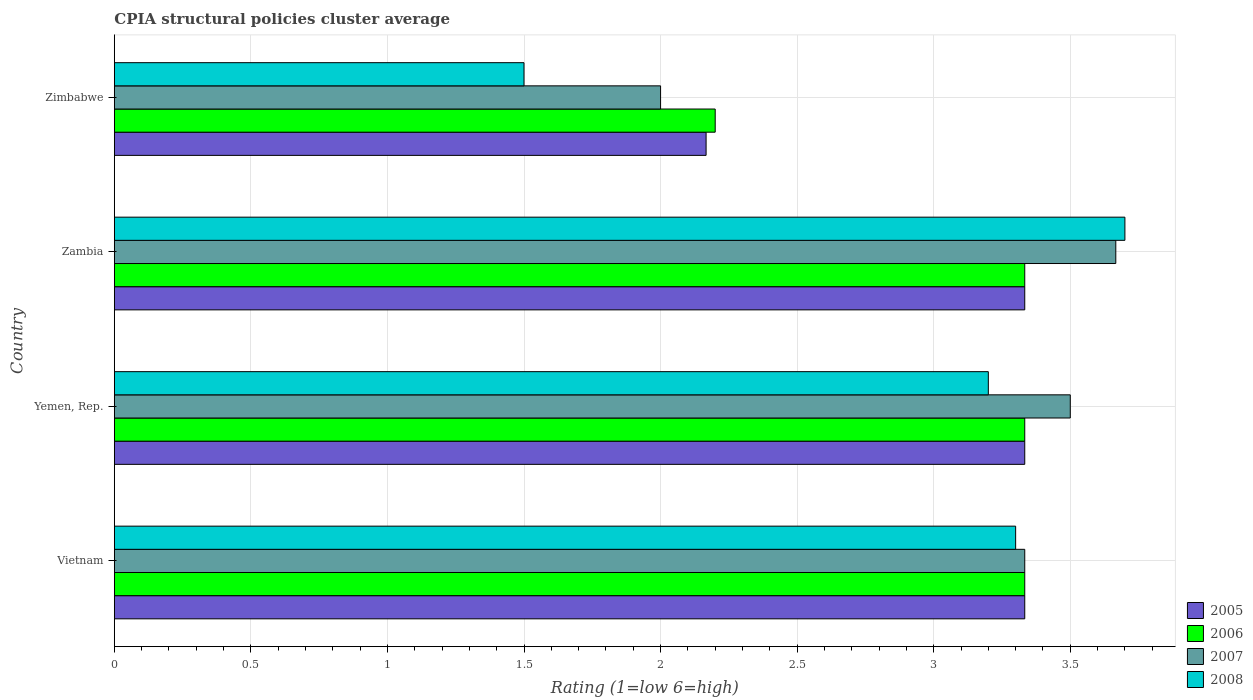How many different coloured bars are there?
Your answer should be compact. 4. How many groups of bars are there?
Offer a very short reply. 4. How many bars are there on the 1st tick from the top?
Make the answer very short. 4. What is the label of the 3rd group of bars from the top?
Offer a terse response. Yemen, Rep. In how many cases, is the number of bars for a given country not equal to the number of legend labels?
Provide a succinct answer. 0. What is the CPIA rating in 2008 in Yemen, Rep.?
Give a very brief answer. 3.2. Across all countries, what is the maximum CPIA rating in 2008?
Offer a terse response. 3.7. Across all countries, what is the minimum CPIA rating in 2007?
Offer a terse response. 2. In which country was the CPIA rating in 2008 maximum?
Ensure brevity in your answer.  Zambia. In which country was the CPIA rating in 2005 minimum?
Make the answer very short. Zimbabwe. What is the difference between the CPIA rating in 2005 in Vietnam and that in Zimbabwe?
Ensure brevity in your answer.  1.17. What is the difference between the CPIA rating in 2008 in Yemen, Rep. and the CPIA rating in 2007 in Zimbabwe?
Provide a succinct answer. 1.2. What is the average CPIA rating in 2005 per country?
Give a very brief answer. 3.04. What is the difference between the CPIA rating in 2006 and CPIA rating in 2007 in Yemen, Rep.?
Provide a succinct answer. -0.17. In how many countries, is the CPIA rating in 2007 greater than 3.7 ?
Make the answer very short. 0. What is the ratio of the CPIA rating in 2007 in Vietnam to that in Yemen, Rep.?
Provide a short and direct response. 0.95. Is the CPIA rating in 2006 in Zambia less than that in Zimbabwe?
Make the answer very short. No. What is the difference between the highest and the second highest CPIA rating in 2006?
Provide a short and direct response. 0. What is the difference between the highest and the lowest CPIA rating in 2008?
Make the answer very short. 2.2. In how many countries, is the CPIA rating in 2007 greater than the average CPIA rating in 2007 taken over all countries?
Give a very brief answer. 3. What does the 4th bar from the bottom in Zimbabwe represents?
Keep it short and to the point. 2008. Does the graph contain any zero values?
Make the answer very short. No. How many legend labels are there?
Your answer should be compact. 4. How are the legend labels stacked?
Make the answer very short. Vertical. What is the title of the graph?
Provide a succinct answer. CPIA structural policies cluster average. What is the label or title of the X-axis?
Make the answer very short. Rating (1=low 6=high). What is the Rating (1=low 6=high) in 2005 in Vietnam?
Keep it short and to the point. 3.33. What is the Rating (1=low 6=high) in 2006 in Vietnam?
Offer a very short reply. 3.33. What is the Rating (1=low 6=high) of 2007 in Vietnam?
Make the answer very short. 3.33. What is the Rating (1=low 6=high) in 2008 in Vietnam?
Provide a short and direct response. 3.3. What is the Rating (1=low 6=high) in 2005 in Yemen, Rep.?
Provide a succinct answer. 3.33. What is the Rating (1=low 6=high) of 2006 in Yemen, Rep.?
Make the answer very short. 3.33. What is the Rating (1=low 6=high) of 2005 in Zambia?
Your answer should be very brief. 3.33. What is the Rating (1=low 6=high) in 2006 in Zambia?
Your answer should be compact. 3.33. What is the Rating (1=low 6=high) of 2007 in Zambia?
Ensure brevity in your answer.  3.67. What is the Rating (1=low 6=high) of 2008 in Zambia?
Make the answer very short. 3.7. What is the Rating (1=low 6=high) of 2005 in Zimbabwe?
Provide a succinct answer. 2.17. Across all countries, what is the maximum Rating (1=low 6=high) of 2005?
Your answer should be compact. 3.33. Across all countries, what is the maximum Rating (1=low 6=high) of 2006?
Provide a short and direct response. 3.33. Across all countries, what is the maximum Rating (1=low 6=high) of 2007?
Your answer should be very brief. 3.67. Across all countries, what is the maximum Rating (1=low 6=high) of 2008?
Keep it short and to the point. 3.7. Across all countries, what is the minimum Rating (1=low 6=high) in 2005?
Offer a very short reply. 2.17. Across all countries, what is the minimum Rating (1=low 6=high) in 2006?
Provide a short and direct response. 2.2. What is the total Rating (1=low 6=high) of 2005 in the graph?
Offer a terse response. 12.17. What is the difference between the Rating (1=low 6=high) in 2006 in Vietnam and that in Yemen, Rep.?
Make the answer very short. 0. What is the difference between the Rating (1=low 6=high) in 2007 in Vietnam and that in Yemen, Rep.?
Give a very brief answer. -0.17. What is the difference between the Rating (1=low 6=high) in 2007 in Vietnam and that in Zambia?
Your answer should be very brief. -0.33. What is the difference between the Rating (1=low 6=high) of 2008 in Vietnam and that in Zambia?
Your answer should be very brief. -0.4. What is the difference between the Rating (1=low 6=high) of 2005 in Vietnam and that in Zimbabwe?
Your response must be concise. 1.17. What is the difference between the Rating (1=low 6=high) in 2006 in Vietnam and that in Zimbabwe?
Offer a very short reply. 1.13. What is the difference between the Rating (1=low 6=high) of 2007 in Vietnam and that in Zimbabwe?
Offer a terse response. 1.33. What is the difference between the Rating (1=low 6=high) of 2005 in Yemen, Rep. and that in Zambia?
Your answer should be very brief. 0. What is the difference between the Rating (1=low 6=high) of 2008 in Yemen, Rep. and that in Zambia?
Keep it short and to the point. -0.5. What is the difference between the Rating (1=low 6=high) in 2006 in Yemen, Rep. and that in Zimbabwe?
Provide a succinct answer. 1.13. What is the difference between the Rating (1=low 6=high) in 2007 in Yemen, Rep. and that in Zimbabwe?
Provide a short and direct response. 1.5. What is the difference between the Rating (1=low 6=high) in 2008 in Yemen, Rep. and that in Zimbabwe?
Your response must be concise. 1.7. What is the difference between the Rating (1=low 6=high) in 2005 in Zambia and that in Zimbabwe?
Offer a terse response. 1.17. What is the difference between the Rating (1=low 6=high) of 2006 in Zambia and that in Zimbabwe?
Your response must be concise. 1.13. What is the difference between the Rating (1=low 6=high) in 2005 in Vietnam and the Rating (1=low 6=high) in 2008 in Yemen, Rep.?
Your answer should be compact. 0.13. What is the difference between the Rating (1=low 6=high) in 2006 in Vietnam and the Rating (1=low 6=high) in 2007 in Yemen, Rep.?
Ensure brevity in your answer.  -0.17. What is the difference between the Rating (1=low 6=high) in 2006 in Vietnam and the Rating (1=low 6=high) in 2008 in Yemen, Rep.?
Offer a terse response. 0.13. What is the difference between the Rating (1=low 6=high) of 2007 in Vietnam and the Rating (1=low 6=high) of 2008 in Yemen, Rep.?
Provide a short and direct response. 0.13. What is the difference between the Rating (1=low 6=high) in 2005 in Vietnam and the Rating (1=low 6=high) in 2008 in Zambia?
Your response must be concise. -0.37. What is the difference between the Rating (1=low 6=high) of 2006 in Vietnam and the Rating (1=low 6=high) of 2007 in Zambia?
Your answer should be compact. -0.33. What is the difference between the Rating (1=low 6=high) of 2006 in Vietnam and the Rating (1=low 6=high) of 2008 in Zambia?
Make the answer very short. -0.37. What is the difference between the Rating (1=low 6=high) in 2007 in Vietnam and the Rating (1=low 6=high) in 2008 in Zambia?
Ensure brevity in your answer.  -0.37. What is the difference between the Rating (1=low 6=high) of 2005 in Vietnam and the Rating (1=low 6=high) of 2006 in Zimbabwe?
Provide a succinct answer. 1.13. What is the difference between the Rating (1=low 6=high) in 2005 in Vietnam and the Rating (1=low 6=high) in 2007 in Zimbabwe?
Make the answer very short. 1.33. What is the difference between the Rating (1=low 6=high) of 2005 in Vietnam and the Rating (1=low 6=high) of 2008 in Zimbabwe?
Your response must be concise. 1.83. What is the difference between the Rating (1=low 6=high) of 2006 in Vietnam and the Rating (1=low 6=high) of 2008 in Zimbabwe?
Provide a short and direct response. 1.83. What is the difference between the Rating (1=low 6=high) in 2007 in Vietnam and the Rating (1=low 6=high) in 2008 in Zimbabwe?
Give a very brief answer. 1.83. What is the difference between the Rating (1=low 6=high) of 2005 in Yemen, Rep. and the Rating (1=low 6=high) of 2008 in Zambia?
Ensure brevity in your answer.  -0.37. What is the difference between the Rating (1=low 6=high) in 2006 in Yemen, Rep. and the Rating (1=low 6=high) in 2008 in Zambia?
Your answer should be very brief. -0.37. What is the difference between the Rating (1=low 6=high) in 2007 in Yemen, Rep. and the Rating (1=low 6=high) in 2008 in Zambia?
Offer a very short reply. -0.2. What is the difference between the Rating (1=low 6=high) of 2005 in Yemen, Rep. and the Rating (1=low 6=high) of 2006 in Zimbabwe?
Ensure brevity in your answer.  1.13. What is the difference between the Rating (1=low 6=high) in 2005 in Yemen, Rep. and the Rating (1=low 6=high) in 2008 in Zimbabwe?
Provide a succinct answer. 1.83. What is the difference between the Rating (1=low 6=high) in 2006 in Yemen, Rep. and the Rating (1=low 6=high) in 2007 in Zimbabwe?
Ensure brevity in your answer.  1.33. What is the difference between the Rating (1=low 6=high) in 2006 in Yemen, Rep. and the Rating (1=low 6=high) in 2008 in Zimbabwe?
Provide a succinct answer. 1.83. What is the difference between the Rating (1=low 6=high) in 2005 in Zambia and the Rating (1=low 6=high) in 2006 in Zimbabwe?
Provide a short and direct response. 1.13. What is the difference between the Rating (1=low 6=high) of 2005 in Zambia and the Rating (1=low 6=high) of 2008 in Zimbabwe?
Provide a succinct answer. 1.83. What is the difference between the Rating (1=low 6=high) in 2006 in Zambia and the Rating (1=low 6=high) in 2007 in Zimbabwe?
Offer a very short reply. 1.33. What is the difference between the Rating (1=low 6=high) in 2006 in Zambia and the Rating (1=low 6=high) in 2008 in Zimbabwe?
Ensure brevity in your answer.  1.83. What is the difference between the Rating (1=low 6=high) in 2007 in Zambia and the Rating (1=low 6=high) in 2008 in Zimbabwe?
Keep it short and to the point. 2.17. What is the average Rating (1=low 6=high) of 2005 per country?
Your answer should be compact. 3.04. What is the average Rating (1=low 6=high) of 2006 per country?
Your answer should be compact. 3.05. What is the average Rating (1=low 6=high) in 2007 per country?
Your answer should be very brief. 3.12. What is the average Rating (1=low 6=high) of 2008 per country?
Ensure brevity in your answer.  2.92. What is the difference between the Rating (1=low 6=high) of 2005 and Rating (1=low 6=high) of 2006 in Vietnam?
Make the answer very short. 0. What is the difference between the Rating (1=low 6=high) in 2005 and Rating (1=low 6=high) in 2007 in Vietnam?
Your answer should be compact. 0. What is the difference between the Rating (1=low 6=high) in 2006 and Rating (1=low 6=high) in 2007 in Vietnam?
Provide a short and direct response. 0. What is the difference between the Rating (1=low 6=high) of 2006 and Rating (1=low 6=high) of 2008 in Vietnam?
Give a very brief answer. 0.03. What is the difference between the Rating (1=low 6=high) in 2005 and Rating (1=low 6=high) in 2008 in Yemen, Rep.?
Provide a succinct answer. 0.13. What is the difference between the Rating (1=low 6=high) of 2006 and Rating (1=low 6=high) of 2008 in Yemen, Rep.?
Your answer should be compact. 0.13. What is the difference between the Rating (1=low 6=high) of 2005 and Rating (1=low 6=high) of 2007 in Zambia?
Ensure brevity in your answer.  -0.33. What is the difference between the Rating (1=low 6=high) in 2005 and Rating (1=low 6=high) in 2008 in Zambia?
Your answer should be compact. -0.37. What is the difference between the Rating (1=low 6=high) of 2006 and Rating (1=low 6=high) of 2007 in Zambia?
Your response must be concise. -0.33. What is the difference between the Rating (1=low 6=high) of 2006 and Rating (1=low 6=high) of 2008 in Zambia?
Your response must be concise. -0.37. What is the difference between the Rating (1=low 6=high) of 2007 and Rating (1=low 6=high) of 2008 in Zambia?
Offer a very short reply. -0.03. What is the difference between the Rating (1=low 6=high) in 2005 and Rating (1=low 6=high) in 2006 in Zimbabwe?
Your response must be concise. -0.03. What is the difference between the Rating (1=low 6=high) in 2005 and Rating (1=low 6=high) in 2007 in Zimbabwe?
Provide a short and direct response. 0.17. What is the difference between the Rating (1=low 6=high) of 2006 and Rating (1=low 6=high) of 2007 in Zimbabwe?
Give a very brief answer. 0.2. What is the difference between the Rating (1=low 6=high) in 2006 and Rating (1=low 6=high) in 2008 in Zimbabwe?
Your answer should be very brief. 0.7. What is the ratio of the Rating (1=low 6=high) of 2005 in Vietnam to that in Yemen, Rep.?
Your response must be concise. 1. What is the ratio of the Rating (1=low 6=high) in 2006 in Vietnam to that in Yemen, Rep.?
Make the answer very short. 1. What is the ratio of the Rating (1=low 6=high) in 2008 in Vietnam to that in Yemen, Rep.?
Give a very brief answer. 1.03. What is the ratio of the Rating (1=low 6=high) of 2005 in Vietnam to that in Zambia?
Keep it short and to the point. 1. What is the ratio of the Rating (1=low 6=high) in 2008 in Vietnam to that in Zambia?
Ensure brevity in your answer.  0.89. What is the ratio of the Rating (1=low 6=high) in 2005 in Vietnam to that in Zimbabwe?
Offer a very short reply. 1.54. What is the ratio of the Rating (1=low 6=high) of 2006 in Vietnam to that in Zimbabwe?
Your answer should be compact. 1.52. What is the ratio of the Rating (1=low 6=high) of 2007 in Vietnam to that in Zimbabwe?
Your answer should be very brief. 1.67. What is the ratio of the Rating (1=low 6=high) in 2005 in Yemen, Rep. to that in Zambia?
Offer a terse response. 1. What is the ratio of the Rating (1=low 6=high) of 2006 in Yemen, Rep. to that in Zambia?
Your response must be concise. 1. What is the ratio of the Rating (1=low 6=high) in 2007 in Yemen, Rep. to that in Zambia?
Give a very brief answer. 0.95. What is the ratio of the Rating (1=low 6=high) in 2008 in Yemen, Rep. to that in Zambia?
Ensure brevity in your answer.  0.86. What is the ratio of the Rating (1=low 6=high) of 2005 in Yemen, Rep. to that in Zimbabwe?
Your answer should be very brief. 1.54. What is the ratio of the Rating (1=low 6=high) of 2006 in Yemen, Rep. to that in Zimbabwe?
Provide a succinct answer. 1.52. What is the ratio of the Rating (1=low 6=high) of 2008 in Yemen, Rep. to that in Zimbabwe?
Provide a succinct answer. 2.13. What is the ratio of the Rating (1=low 6=high) in 2005 in Zambia to that in Zimbabwe?
Your answer should be compact. 1.54. What is the ratio of the Rating (1=low 6=high) of 2006 in Zambia to that in Zimbabwe?
Provide a succinct answer. 1.52. What is the ratio of the Rating (1=low 6=high) of 2007 in Zambia to that in Zimbabwe?
Keep it short and to the point. 1.83. What is the ratio of the Rating (1=low 6=high) of 2008 in Zambia to that in Zimbabwe?
Your answer should be very brief. 2.47. What is the difference between the highest and the lowest Rating (1=low 6=high) in 2006?
Offer a very short reply. 1.13. What is the difference between the highest and the lowest Rating (1=low 6=high) of 2008?
Offer a very short reply. 2.2. 